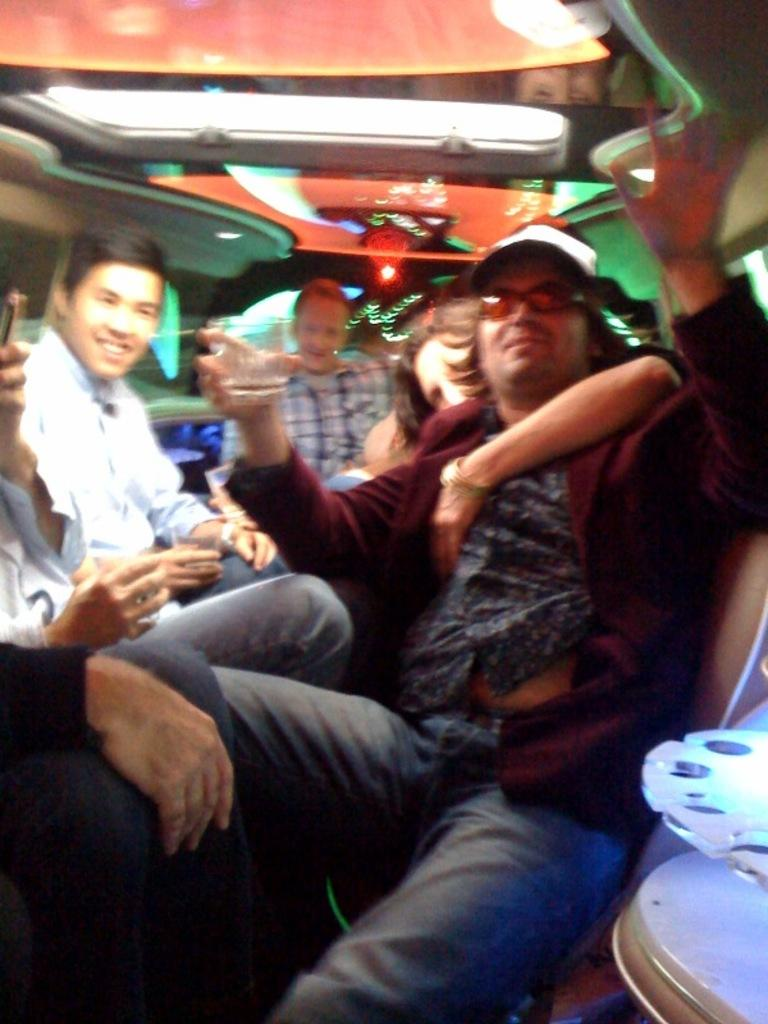Who or what is present in the image? There are people in the image. What are the people doing in the image? The people are drinking wine. How are the people positioned in the image? The people are sitting on chairs. What can be seen at the top of the image? There are lights visible at the top of the image. What type of vegetable is being used as a centerpiece on the table in the image? There is no vegetable or centerpiece mentioned in the image; it only describes people drinking wine and sitting on chairs. 